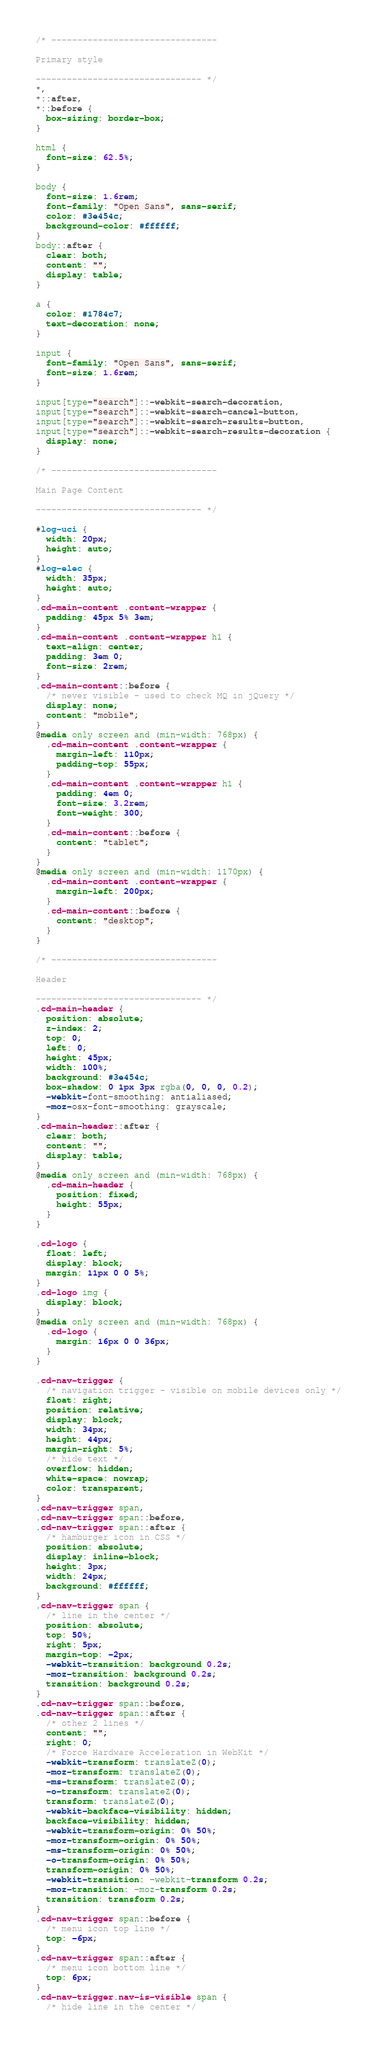<code> <loc_0><loc_0><loc_500><loc_500><_CSS_>/* -------------------------------- 

Primary style

-------------------------------- */
*,
*::after,
*::before {
  box-sizing: border-box;
}

html {
  font-size: 62.5%;
}

body {
  font-size: 1.6rem;
  font-family: "Open Sans", sans-serif;
  color: #3e454c;
  background-color: #ffffff;
}
body::after {
  clear: both;
  content: "";
  display: table;
}

a {
  color: #1784c7;
  text-decoration: none;
}

input {
  font-family: "Open Sans", sans-serif;
  font-size: 1.6rem;
}

input[type="search"]::-webkit-search-decoration,
input[type="search"]::-webkit-search-cancel-button,
input[type="search"]::-webkit-search-results-button,
input[type="search"]::-webkit-search-results-decoration {
  display: none;
}

/* -------------------------------- 

Main Page Content

-------------------------------- */

#log-uci {
  width: 20px;
  height: auto;
}
#log-elec {
  width: 35px;
  height: auto;
}
.cd-main-content .content-wrapper {
  padding: 45px 5% 3em;
}
.cd-main-content .content-wrapper h1 {
  text-align: center;
  padding: 3em 0;
  font-size: 2rem;
}
.cd-main-content::before {
  /* never visible - used to check MQ in jQuery */
  display: none;
  content: "mobile";
}
@media only screen and (min-width: 768px) {
  .cd-main-content .content-wrapper {
    margin-left: 110px;
    padding-top: 55px;
  }
  .cd-main-content .content-wrapper h1 {
    padding: 4em 0;
    font-size: 3.2rem;
    font-weight: 300;
  }
  .cd-main-content::before {
    content: "tablet";
  }
}
@media only screen and (min-width: 1170px) {
  .cd-main-content .content-wrapper {
    margin-left: 200px;
  }
  .cd-main-content::before {
    content: "desktop";
  }
}

/* -------------------------------- 

Header

-------------------------------- */
.cd-main-header {
  position: absolute;
  z-index: 2;
  top: 0;
  left: 0;
  height: 45px;
  width: 100%;
  background: #3e454c;
  box-shadow: 0 1px 3px rgba(0, 0, 0, 0.2);
  -webkit-font-smoothing: antialiased;
  -moz-osx-font-smoothing: grayscale;
}
.cd-main-header::after {
  clear: both;
  content: "";
  display: table;
}
@media only screen and (min-width: 768px) {
  .cd-main-header {
    position: fixed;
    height: 55px;
  }
}

.cd-logo {
  float: left;
  display: block;
  margin: 11px 0 0 5%;
}
.cd-logo img {
  display: block;
}
@media only screen and (min-width: 768px) {
  .cd-logo {
    margin: 16px 0 0 36px;
  }
}

.cd-nav-trigger {
  /* navigation trigger - visible on mobile devices only */
  float: right;
  position: relative;
  display: block;
  width: 34px;
  height: 44px;
  margin-right: 5%;
  /* hide text */
  overflow: hidden;
  white-space: nowrap;
  color: transparent;
}
.cd-nav-trigger span,
.cd-nav-trigger span::before,
.cd-nav-trigger span::after {
  /* hamburger icon in CSS */
  position: absolute;
  display: inline-block;
  height: 3px;
  width: 24px;
  background: #ffffff;
}
.cd-nav-trigger span {
  /* line in the center */
  position: absolute;
  top: 50%;
  right: 5px;
  margin-top: -2px;
  -webkit-transition: background 0.2s;
  -moz-transition: background 0.2s;
  transition: background 0.2s;
}
.cd-nav-trigger span::before,
.cd-nav-trigger span::after {
  /* other 2 lines */
  content: "";
  right: 0;
  /* Force Hardware Acceleration in WebKit */
  -webkit-transform: translateZ(0);
  -moz-transform: translateZ(0);
  -ms-transform: translateZ(0);
  -o-transform: translateZ(0);
  transform: translateZ(0);
  -webkit-backface-visibility: hidden;
  backface-visibility: hidden;
  -webkit-transform-origin: 0% 50%;
  -moz-transform-origin: 0% 50%;
  -ms-transform-origin: 0% 50%;
  -o-transform-origin: 0% 50%;
  transform-origin: 0% 50%;
  -webkit-transition: -webkit-transform 0.2s;
  -moz-transition: -moz-transform 0.2s;
  transition: transform 0.2s;
}
.cd-nav-trigger span::before {
  /* menu icon top line */
  top: -6px;
}
.cd-nav-trigger span::after {
  /* menu icon bottom line */
  top: 6px;
}
.cd-nav-trigger.nav-is-visible span {
  /* hide line in the center */</code> 